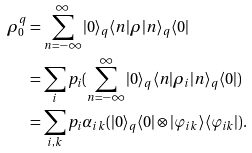<formula> <loc_0><loc_0><loc_500><loc_500>\rho ^ { q } _ { 0 } & = \sum _ { n = - \infty } ^ { \infty } | 0 \rangle _ { q } \langle n | \rho | n \rangle _ { q } \langle 0 | \\ & = \sum _ { i } p _ { i } ( \sum _ { n = - \infty } ^ { \infty } | 0 \rangle _ { q } \langle n | \rho _ { i } | n \rangle _ { q } \langle 0 | ) \\ & = \sum _ { i , k } p _ { i } \alpha _ { i k } ( | 0 \rangle _ { q } \langle 0 | \otimes | \varphi _ { i k } \rangle \langle \varphi _ { i k } | ) .</formula> 